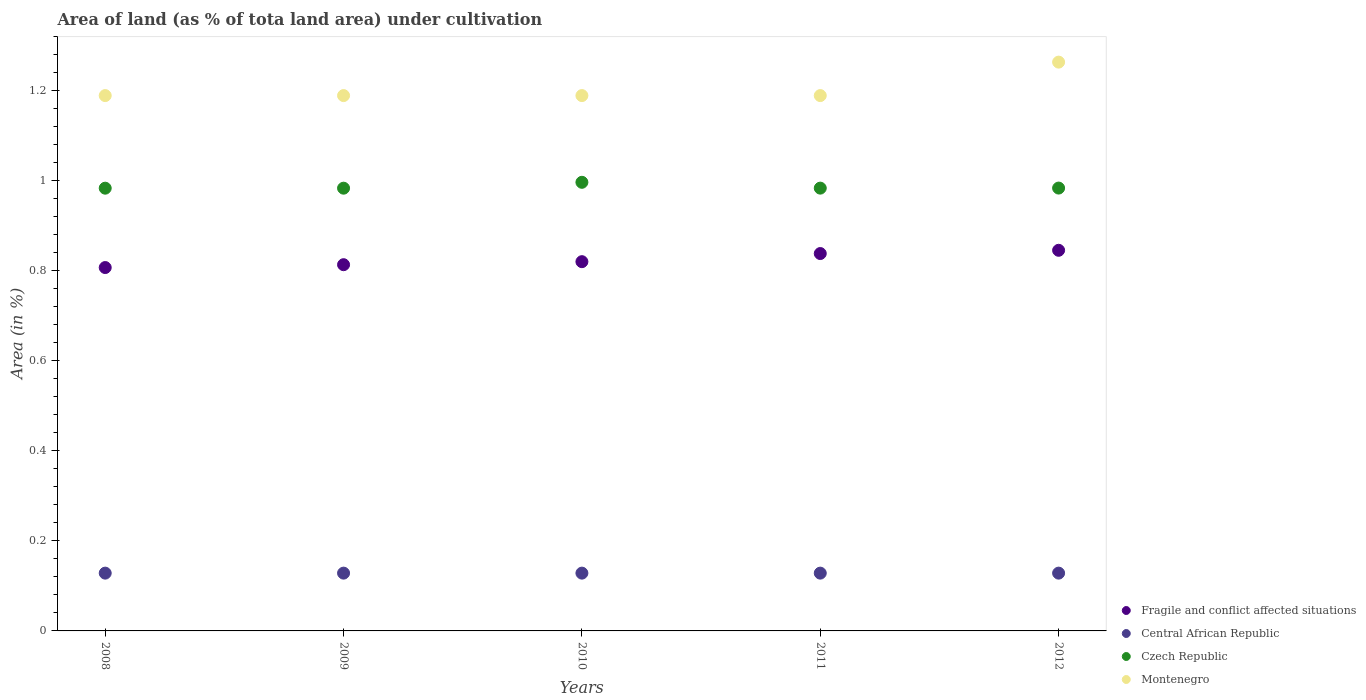How many different coloured dotlines are there?
Your answer should be very brief. 4. Is the number of dotlines equal to the number of legend labels?
Provide a succinct answer. Yes. What is the percentage of land under cultivation in Czech Republic in 2010?
Offer a terse response. 1. Across all years, what is the maximum percentage of land under cultivation in Czech Republic?
Give a very brief answer. 1. Across all years, what is the minimum percentage of land under cultivation in Montenegro?
Provide a succinct answer. 1.19. In which year was the percentage of land under cultivation in Fragile and conflict affected situations minimum?
Give a very brief answer. 2008. What is the total percentage of land under cultivation in Montenegro in the graph?
Offer a terse response. 6.02. What is the difference between the percentage of land under cultivation in Fragile and conflict affected situations in 2008 and the percentage of land under cultivation in Central African Republic in 2009?
Offer a very short reply. 0.68. What is the average percentage of land under cultivation in Montenegro per year?
Make the answer very short. 1.2. In the year 2010, what is the difference between the percentage of land under cultivation in Czech Republic and percentage of land under cultivation in Montenegro?
Your response must be concise. -0.19. In how many years, is the percentage of land under cultivation in Montenegro greater than 0.56 %?
Give a very brief answer. 5. What is the ratio of the percentage of land under cultivation in Montenegro in 2008 to that in 2011?
Your answer should be very brief. 1. Is the percentage of land under cultivation in Montenegro in 2010 less than that in 2011?
Your answer should be very brief. No. What is the difference between the highest and the lowest percentage of land under cultivation in Czech Republic?
Give a very brief answer. 0.01. Is the sum of the percentage of land under cultivation in Czech Republic in 2010 and 2012 greater than the maximum percentage of land under cultivation in Montenegro across all years?
Provide a short and direct response. Yes. Is it the case that in every year, the sum of the percentage of land under cultivation in Central African Republic and percentage of land under cultivation in Czech Republic  is greater than the sum of percentage of land under cultivation in Fragile and conflict affected situations and percentage of land under cultivation in Montenegro?
Give a very brief answer. No. Does the percentage of land under cultivation in Central African Republic monotonically increase over the years?
Make the answer very short. No. Is the percentage of land under cultivation in Czech Republic strictly less than the percentage of land under cultivation in Fragile and conflict affected situations over the years?
Give a very brief answer. No. How many dotlines are there?
Your answer should be very brief. 4. What is the difference between two consecutive major ticks on the Y-axis?
Your answer should be very brief. 0.2. Are the values on the major ticks of Y-axis written in scientific E-notation?
Ensure brevity in your answer.  No. Does the graph contain grids?
Your answer should be very brief. No. Where does the legend appear in the graph?
Offer a terse response. Bottom right. How many legend labels are there?
Your answer should be compact. 4. What is the title of the graph?
Ensure brevity in your answer.  Area of land (as % of tota land area) under cultivation. What is the label or title of the Y-axis?
Ensure brevity in your answer.  Area (in %). What is the Area (in %) of Fragile and conflict affected situations in 2008?
Your answer should be very brief. 0.81. What is the Area (in %) in Central African Republic in 2008?
Your answer should be compact. 0.13. What is the Area (in %) of Czech Republic in 2008?
Give a very brief answer. 0.98. What is the Area (in %) of Montenegro in 2008?
Your answer should be very brief. 1.19. What is the Area (in %) in Fragile and conflict affected situations in 2009?
Make the answer very short. 0.81. What is the Area (in %) of Central African Republic in 2009?
Provide a succinct answer. 0.13. What is the Area (in %) in Czech Republic in 2009?
Provide a short and direct response. 0.98. What is the Area (in %) in Montenegro in 2009?
Offer a terse response. 1.19. What is the Area (in %) in Fragile and conflict affected situations in 2010?
Ensure brevity in your answer.  0.82. What is the Area (in %) in Central African Republic in 2010?
Offer a terse response. 0.13. What is the Area (in %) in Czech Republic in 2010?
Offer a very short reply. 1. What is the Area (in %) of Montenegro in 2010?
Provide a short and direct response. 1.19. What is the Area (in %) of Fragile and conflict affected situations in 2011?
Provide a succinct answer. 0.84. What is the Area (in %) in Central African Republic in 2011?
Offer a very short reply. 0.13. What is the Area (in %) of Czech Republic in 2011?
Offer a terse response. 0.98. What is the Area (in %) in Montenegro in 2011?
Keep it short and to the point. 1.19. What is the Area (in %) in Fragile and conflict affected situations in 2012?
Provide a short and direct response. 0.85. What is the Area (in %) of Central African Republic in 2012?
Give a very brief answer. 0.13. What is the Area (in %) of Czech Republic in 2012?
Make the answer very short. 0.98. What is the Area (in %) in Montenegro in 2012?
Your answer should be compact. 1.26. Across all years, what is the maximum Area (in %) in Fragile and conflict affected situations?
Offer a very short reply. 0.85. Across all years, what is the maximum Area (in %) in Central African Republic?
Your answer should be very brief. 0.13. Across all years, what is the maximum Area (in %) in Czech Republic?
Give a very brief answer. 1. Across all years, what is the maximum Area (in %) of Montenegro?
Your answer should be very brief. 1.26. Across all years, what is the minimum Area (in %) in Fragile and conflict affected situations?
Offer a very short reply. 0.81. Across all years, what is the minimum Area (in %) in Central African Republic?
Provide a short and direct response. 0.13. Across all years, what is the minimum Area (in %) of Czech Republic?
Your response must be concise. 0.98. Across all years, what is the minimum Area (in %) of Montenegro?
Make the answer very short. 1.19. What is the total Area (in %) of Fragile and conflict affected situations in the graph?
Ensure brevity in your answer.  4.13. What is the total Area (in %) of Central African Republic in the graph?
Give a very brief answer. 0.64. What is the total Area (in %) of Czech Republic in the graph?
Your answer should be compact. 4.93. What is the total Area (in %) of Montenegro in the graph?
Make the answer very short. 6.02. What is the difference between the Area (in %) in Fragile and conflict affected situations in 2008 and that in 2009?
Keep it short and to the point. -0.01. What is the difference between the Area (in %) of Central African Republic in 2008 and that in 2009?
Make the answer very short. 0. What is the difference between the Area (in %) of Fragile and conflict affected situations in 2008 and that in 2010?
Your answer should be very brief. -0.01. What is the difference between the Area (in %) in Czech Republic in 2008 and that in 2010?
Offer a very short reply. -0.01. What is the difference between the Area (in %) of Fragile and conflict affected situations in 2008 and that in 2011?
Offer a very short reply. -0.03. What is the difference between the Area (in %) of Czech Republic in 2008 and that in 2011?
Offer a terse response. -0. What is the difference between the Area (in %) in Montenegro in 2008 and that in 2011?
Your response must be concise. 0. What is the difference between the Area (in %) in Fragile and conflict affected situations in 2008 and that in 2012?
Ensure brevity in your answer.  -0.04. What is the difference between the Area (in %) in Central African Republic in 2008 and that in 2012?
Offer a terse response. 0. What is the difference between the Area (in %) of Czech Republic in 2008 and that in 2012?
Offer a terse response. -0. What is the difference between the Area (in %) of Montenegro in 2008 and that in 2012?
Offer a terse response. -0.07. What is the difference between the Area (in %) of Fragile and conflict affected situations in 2009 and that in 2010?
Provide a short and direct response. -0.01. What is the difference between the Area (in %) of Czech Republic in 2009 and that in 2010?
Your answer should be very brief. -0.01. What is the difference between the Area (in %) in Fragile and conflict affected situations in 2009 and that in 2011?
Keep it short and to the point. -0.02. What is the difference between the Area (in %) in Central African Republic in 2009 and that in 2011?
Give a very brief answer. 0. What is the difference between the Area (in %) in Czech Republic in 2009 and that in 2011?
Your response must be concise. -0. What is the difference between the Area (in %) of Montenegro in 2009 and that in 2011?
Offer a very short reply. 0. What is the difference between the Area (in %) in Fragile and conflict affected situations in 2009 and that in 2012?
Ensure brevity in your answer.  -0.03. What is the difference between the Area (in %) of Czech Republic in 2009 and that in 2012?
Provide a short and direct response. -0. What is the difference between the Area (in %) in Montenegro in 2009 and that in 2012?
Your response must be concise. -0.07. What is the difference between the Area (in %) of Fragile and conflict affected situations in 2010 and that in 2011?
Provide a succinct answer. -0.02. What is the difference between the Area (in %) of Czech Republic in 2010 and that in 2011?
Offer a terse response. 0.01. What is the difference between the Area (in %) in Montenegro in 2010 and that in 2011?
Provide a succinct answer. 0. What is the difference between the Area (in %) in Fragile and conflict affected situations in 2010 and that in 2012?
Your answer should be very brief. -0.03. What is the difference between the Area (in %) in Czech Republic in 2010 and that in 2012?
Your answer should be compact. 0.01. What is the difference between the Area (in %) of Montenegro in 2010 and that in 2012?
Offer a terse response. -0.07. What is the difference between the Area (in %) in Fragile and conflict affected situations in 2011 and that in 2012?
Your response must be concise. -0.01. What is the difference between the Area (in %) of Czech Republic in 2011 and that in 2012?
Offer a very short reply. -0. What is the difference between the Area (in %) in Montenegro in 2011 and that in 2012?
Make the answer very short. -0.07. What is the difference between the Area (in %) of Fragile and conflict affected situations in 2008 and the Area (in %) of Central African Republic in 2009?
Give a very brief answer. 0.68. What is the difference between the Area (in %) of Fragile and conflict affected situations in 2008 and the Area (in %) of Czech Republic in 2009?
Provide a succinct answer. -0.18. What is the difference between the Area (in %) of Fragile and conflict affected situations in 2008 and the Area (in %) of Montenegro in 2009?
Your response must be concise. -0.38. What is the difference between the Area (in %) in Central African Republic in 2008 and the Area (in %) in Czech Republic in 2009?
Your answer should be very brief. -0.86. What is the difference between the Area (in %) of Central African Republic in 2008 and the Area (in %) of Montenegro in 2009?
Offer a terse response. -1.06. What is the difference between the Area (in %) in Czech Republic in 2008 and the Area (in %) in Montenegro in 2009?
Offer a very short reply. -0.21. What is the difference between the Area (in %) in Fragile and conflict affected situations in 2008 and the Area (in %) in Central African Republic in 2010?
Make the answer very short. 0.68. What is the difference between the Area (in %) in Fragile and conflict affected situations in 2008 and the Area (in %) in Czech Republic in 2010?
Offer a very short reply. -0.19. What is the difference between the Area (in %) of Fragile and conflict affected situations in 2008 and the Area (in %) of Montenegro in 2010?
Give a very brief answer. -0.38. What is the difference between the Area (in %) of Central African Republic in 2008 and the Area (in %) of Czech Republic in 2010?
Keep it short and to the point. -0.87. What is the difference between the Area (in %) of Central African Republic in 2008 and the Area (in %) of Montenegro in 2010?
Give a very brief answer. -1.06. What is the difference between the Area (in %) of Czech Republic in 2008 and the Area (in %) of Montenegro in 2010?
Ensure brevity in your answer.  -0.21. What is the difference between the Area (in %) of Fragile and conflict affected situations in 2008 and the Area (in %) of Central African Republic in 2011?
Provide a succinct answer. 0.68. What is the difference between the Area (in %) of Fragile and conflict affected situations in 2008 and the Area (in %) of Czech Republic in 2011?
Your response must be concise. -0.18. What is the difference between the Area (in %) of Fragile and conflict affected situations in 2008 and the Area (in %) of Montenegro in 2011?
Your answer should be very brief. -0.38. What is the difference between the Area (in %) in Central African Republic in 2008 and the Area (in %) in Czech Republic in 2011?
Provide a short and direct response. -0.86. What is the difference between the Area (in %) of Central African Republic in 2008 and the Area (in %) of Montenegro in 2011?
Your answer should be very brief. -1.06. What is the difference between the Area (in %) in Czech Republic in 2008 and the Area (in %) in Montenegro in 2011?
Offer a very short reply. -0.21. What is the difference between the Area (in %) of Fragile and conflict affected situations in 2008 and the Area (in %) of Central African Republic in 2012?
Give a very brief answer. 0.68. What is the difference between the Area (in %) in Fragile and conflict affected situations in 2008 and the Area (in %) in Czech Republic in 2012?
Your response must be concise. -0.18. What is the difference between the Area (in %) in Fragile and conflict affected situations in 2008 and the Area (in %) in Montenegro in 2012?
Your answer should be very brief. -0.46. What is the difference between the Area (in %) of Central African Republic in 2008 and the Area (in %) of Czech Republic in 2012?
Provide a short and direct response. -0.86. What is the difference between the Area (in %) in Central African Republic in 2008 and the Area (in %) in Montenegro in 2012?
Give a very brief answer. -1.14. What is the difference between the Area (in %) of Czech Republic in 2008 and the Area (in %) of Montenegro in 2012?
Offer a very short reply. -0.28. What is the difference between the Area (in %) of Fragile and conflict affected situations in 2009 and the Area (in %) of Central African Republic in 2010?
Your answer should be compact. 0.69. What is the difference between the Area (in %) in Fragile and conflict affected situations in 2009 and the Area (in %) in Czech Republic in 2010?
Your answer should be very brief. -0.18. What is the difference between the Area (in %) in Fragile and conflict affected situations in 2009 and the Area (in %) in Montenegro in 2010?
Offer a very short reply. -0.38. What is the difference between the Area (in %) of Central African Republic in 2009 and the Area (in %) of Czech Republic in 2010?
Offer a very short reply. -0.87. What is the difference between the Area (in %) in Central African Republic in 2009 and the Area (in %) in Montenegro in 2010?
Your response must be concise. -1.06. What is the difference between the Area (in %) in Czech Republic in 2009 and the Area (in %) in Montenegro in 2010?
Make the answer very short. -0.21. What is the difference between the Area (in %) in Fragile and conflict affected situations in 2009 and the Area (in %) in Central African Republic in 2011?
Offer a very short reply. 0.69. What is the difference between the Area (in %) of Fragile and conflict affected situations in 2009 and the Area (in %) of Czech Republic in 2011?
Ensure brevity in your answer.  -0.17. What is the difference between the Area (in %) of Fragile and conflict affected situations in 2009 and the Area (in %) of Montenegro in 2011?
Your response must be concise. -0.38. What is the difference between the Area (in %) of Central African Republic in 2009 and the Area (in %) of Czech Republic in 2011?
Your response must be concise. -0.86. What is the difference between the Area (in %) in Central African Republic in 2009 and the Area (in %) in Montenegro in 2011?
Make the answer very short. -1.06. What is the difference between the Area (in %) of Czech Republic in 2009 and the Area (in %) of Montenegro in 2011?
Keep it short and to the point. -0.21. What is the difference between the Area (in %) of Fragile and conflict affected situations in 2009 and the Area (in %) of Central African Republic in 2012?
Make the answer very short. 0.69. What is the difference between the Area (in %) in Fragile and conflict affected situations in 2009 and the Area (in %) in Czech Republic in 2012?
Make the answer very short. -0.17. What is the difference between the Area (in %) in Fragile and conflict affected situations in 2009 and the Area (in %) in Montenegro in 2012?
Offer a terse response. -0.45. What is the difference between the Area (in %) in Central African Republic in 2009 and the Area (in %) in Czech Republic in 2012?
Keep it short and to the point. -0.86. What is the difference between the Area (in %) of Central African Republic in 2009 and the Area (in %) of Montenegro in 2012?
Provide a succinct answer. -1.14. What is the difference between the Area (in %) of Czech Republic in 2009 and the Area (in %) of Montenegro in 2012?
Your answer should be compact. -0.28. What is the difference between the Area (in %) of Fragile and conflict affected situations in 2010 and the Area (in %) of Central African Republic in 2011?
Your answer should be compact. 0.69. What is the difference between the Area (in %) of Fragile and conflict affected situations in 2010 and the Area (in %) of Czech Republic in 2011?
Provide a succinct answer. -0.16. What is the difference between the Area (in %) in Fragile and conflict affected situations in 2010 and the Area (in %) in Montenegro in 2011?
Your answer should be very brief. -0.37. What is the difference between the Area (in %) in Central African Republic in 2010 and the Area (in %) in Czech Republic in 2011?
Your answer should be compact. -0.86. What is the difference between the Area (in %) in Central African Republic in 2010 and the Area (in %) in Montenegro in 2011?
Your answer should be compact. -1.06. What is the difference between the Area (in %) of Czech Republic in 2010 and the Area (in %) of Montenegro in 2011?
Ensure brevity in your answer.  -0.19. What is the difference between the Area (in %) in Fragile and conflict affected situations in 2010 and the Area (in %) in Central African Republic in 2012?
Provide a succinct answer. 0.69. What is the difference between the Area (in %) of Fragile and conflict affected situations in 2010 and the Area (in %) of Czech Republic in 2012?
Make the answer very short. -0.16. What is the difference between the Area (in %) of Fragile and conflict affected situations in 2010 and the Area (in %) of Montenegro in 2012?
Make the answer very short. -0.44. What is the difference between the Area (in %) of Central African Republic in 2010 and the Area (in %) of Czech Republic in 2012?
Provide a succinct answer. -0.86. What is the difference between the Area (in %) of Central African Republic in 2010 and the Area (in %) of Montenegro in 2012?
Give a very brief answer. -1.14. What is the difference between the Area (in %) of Czech Republic in 2010 and the Area (in %) of Montenegro in 2012?
Your answer should be very brief. -0.27. What is the difference between the Area (in %) of Fragile and conflict affected situations in 2011 and the Area (in %) of Central African Republic in 2012?
Your response must be concise. 0.71. What is the difference between the Area (in %) in Fragile and conflict affected situations in 2011 and the Area (in %) in Czech Republic in 2012?
Offer a terse response. -0.15. What is the difference between the Area (in %) in Fragile and conflict affected situations in 2011 and the Area (in %) in Montenegro in 2012?
Your response must be concise. -0.43. What is the difference between the Area (in %) of Central African Republic in 2011 and the Area (in %) of Czech Republic in 2012?
Give a very brief answer. -0.86. What is the difference between the Area (in %) in Central African Republic in 2011 and the Area (in %) in Montenegro in 2012?
Offer a very short reply. -1.14. What is the difference between the Area (in %) of Czech Republic in 2011 and the Area (in %) of Montenegro in 2012?
Keep it short and to the point. -0.28. What is the average Area (in %) of Fragile and conflict affected situations per year?
Offer a terse response. 0.83. What is the average Area (in %) of Central African Republic per year?
Offer a terse response. 0.13. What is the average Area (in %) in Czech Republic per year?
Give a very brief answer. 0.99. What is the average Area (in %) in Montenegro per year?
Ensure brevity in your answer.  1.2. In the year 2008, what is the difference between the Area (in %) in Fragile and conflict affected situations and Area (in %) in Central African Republic?
Your answer should be compact. 0.68. In the year 2008, what is the difference between the Area (in %) in Fragile and conflict affected situations and Area (in %) in Czech Republic?
Keep it short and to the point. -0.18. In the year 2008, what is the difference between the Area (in %) of Fragile and conflict affected situations and Area (in %) of Montenegro?
Provide a short and direct response. -0.38. In the year 2008, what is the difference between the Area (in %) in Central African Republic and Area (in %) in Czech Republic?
Keep it short and to the point. -0.86. In the year 2008, what is the difference between the Area (in %) of Central African Republic and Area (in %) of Montenegro?
Your answer should be very brief. -1.06. In the year 2008, what is the difference between the Area (in %) in Czech Republic and Area (in %) in Montenegro?
Provide a short and direct response. -0.21. In the year 2009, what is the difference between the Area (in %) in Fragile and conflict affected situations and Area (in %) in Central African Republic?
Provide a short and direct response. 0.69. In the year 2009, what is the difference between the Area (in %) of Fragile and conflict affected situations and Area (in %) of Czech Republic?
Offer a terse response. -0.17. In the year 2009, what is the difference between the Area (in %) in Fragile and conflict affected situations and Area (in %) in Montenegro?
Make the answer very short. -0.38. In the year 2009, what is the difference between the Area (in %) of Central African Republic and Area (in %) of Czech Republic?
Keep it short and to the point. -0.86. In the year 2009, what is the difference between the Area (in %) in Central African Republic and Area (in %) in Montenegro?
Keep it short and to the point. -1.06. In the year 2009, what is the difference between the Area (in %) of Czech Republic and Area (in %) of Montenegro?
Make the answer very short. -0.21. In the year 2010, what is the difference between the Area (in %) of Fragile and conflict affected situations and Area (in %) of Central African Republic?
Offer a very short reply. 0.69. In the year 2010, what is the difference between the Area (in %) of Fragile and conflict affected situations and Area (in %) of Czech Republic?
Make the answer very short. -0.18. In the year 2010, what is the difference between the Area (in %) of Fragile and conflict affected situations and Area (in %) of Montenegro?
Offer a very short reply. -0.37. In the year 2010, what is the difference between the Area (in %) in Central African Republic and Area (in %) in Czech Republic?
Provide a short and direct response. -0.87. In the year 2010, what is the difference between the Area (in %) in Central African Republic and Area (in %) in Montenegro?
Make the answer very short. -1.06. In the year 2010, what is the difference between the Area (in %) of Czech Republic and Area (in %) of Montenegro?
Offer a terse response. -0.19. In the year 2011, what is the difference between the Area (in %) in Fragile and conflict affected situations and Area (in %) in Central African Republic?
Ensure brevity in your answer.  0.71. In the year 2011, what is the difference between the Area (in %) in Fragile and conflict affected situations and Area (in %) in Czech Republic?
Offer a very short reply. -0.15. In the year 2011, what is the difference between the Area (in %) of Fragile and conflict affected situations and Area (in %) of Montenegro?
Offer a terse response. -0.35. In the year 2011, what is the difference between the Area (in %) of Central African Republic and Area (in %) of Czech Republic?
Your response must be concise. -0.86. In the year 2011, what is the difference between the Area (in %) of Central African Republic and Area (in %) of Montenegro?
Offer a terse response. -1.06. In the year 2011, what is the difference between the Area (in %) of Czech Republic and Area (in %) of Montenegro?
Ensure brevity in your answer.  -0.21. In the year 2012, what is the difference between the Area (in %) in Fragile and conflict affected situations and Area (in %) in Central African Republic?
Give a very brief answer. 0.72. In the year 2012, what is the difference between the Area (in %) in Fragile and conflict affected situations and Area (in %) in Czech Republic?
Make the answer very short. -0.14. In the year 2012, what is the difference between the Area (in %) of Fragile and conflict affected situations and Area (in %) of Montenegro?
Keep it short and to the point. -0.42. In the year 2012, what is the difference between the Area (in %) of Central African Republic and Area (in %) of Czech Republic?
Provide a succinct answer. -0.86. In the year 2012, what is the difference between the Area (in %) of Central African Republic and Area (in %) of Montenegro?
Your answer should be compact. -1.14. In the year 2012, what is the difference between the Area (in %) of Czech Republic and Area (in %) of Montenegro?
Keep it short and to the point. -0.28. What is the ratio of the Area (in %) in Fragile and conflict affected situations in 2008 to that in 2009?
Give a very brief answer. 0.99. What is the ratio of the Area (in %) of Central African Republic in 2008 to that in 2009?
Your answer should be compact. 1. What is the ratio of the Area (in %) in Fragile and conflict affected situations in 2008 to that in 2010?
Your answer should be compact. 0.98. What is the ratio of the Area (in %) of Czech Republic in 2008 to that in 2010?
Keep it short and to the point. 0.99. What is the ratio of the Area (in %) in Montenegro in 2008 to that in 2010?
Provide a short and direct response. 1. What is the ratio of the Area (in %) in Fragile and conflict affected situations in 2008 to that in 2011?
Your answer should be very brief. 0.96. What is the ratio of the Area (in %) of Central African Republic in 2008 to that in 2011?
Provide a succinct answer. 1. What is the ratio of the Area (in %) in Montenegro in 2008 to that in 2011?
Your response must be concise. 1. What is the ratio of the Area (in %) of Fragile and conflict affected situations in 2008 to that in 2012?
Keep it short and to the point. 0.95. What is the ratio of the Area (in %) of Czech Republic in 2008 to that in 2012?
Give a very brief answer. 1. What is the ratio of the Area (in %) of Czech Republic in 2009 to that in 2010?
Make the answer very short. 0.99. What is the ratio of the Area (in %) of Fragile and conflict affected situations in 2009 to that in 2011?
Keep it short and to the point. 0.97. What is the ratio of the Area (in %) in Central African Republic in 2009 to that in 2011?
Ensure brevity in your answer.  1. What is the ratio of the Area (in %) of Montenegro in 2009 to that in 2011?
Your answer should be compact. 1. What is the ratio of the Area (in %) of Fragile and conflict affected situations in 2009 to that in 2012?
Offer a very short reply. 0.96. What is the ratio of the Area (in %) of Czech Republic in 2009 to that in 2012?
Your answer should be compact. 1. What is the ratio of the Area (in %) in Fragile and conflict affected situations in 2010 to that in 2011?
Provide a short and direct response. 0.98. What is the ratio of the Area (in %) of Central African Republic in 2010 to that in 2011?
Offer a terse response. 1. What is the ratio of the Area (in %) in Czech Republic in 2010 to that in 2011?
Your answer should be compact. 1.01. What is the ratio of the Area (in %) of Montenegro in 2010 to that in 2011?
Ensure brevity in your answer.  1. What is the ratio of the Area (in %) in Fragile and conflict affected situations in 2010 to that in 2012?
Ensure brevity in your answer.  0.97. What is the ratio of the Area (in %) in Central African Republic in 2011 to that in 2012?
Keep it short and to the point. 1. What is the difference between the highest and the second highest Area (in %) of Fragile and conflict affected situations?
Ensure brevity in your answer.  0.01. What is the difference between the highest and the second highest Area (in %) in Central African Republic?
Ensure brevity in your answer.  0. What is the difference between the highest and the second highest Area (in %) in Czech Republic?
Give a very brief answer. 0.01. What is the difference between the highest and the second highest Area (in %) of Montenegro?
Your answer should be very brief. 0.07. What is the difference between the highest and the lowest Area (in %) of Fragile and conflict affected situations?
Ensure brevity in your answer.  0.04. What is the difference between the highest and the lowest Area (in %) in Czech Republic?
Provide a short and direct response. 0.01. What is the difference between the highest and the lowest Area (in %) of Montenegro?
Keep it short and to the point. 0.07. 